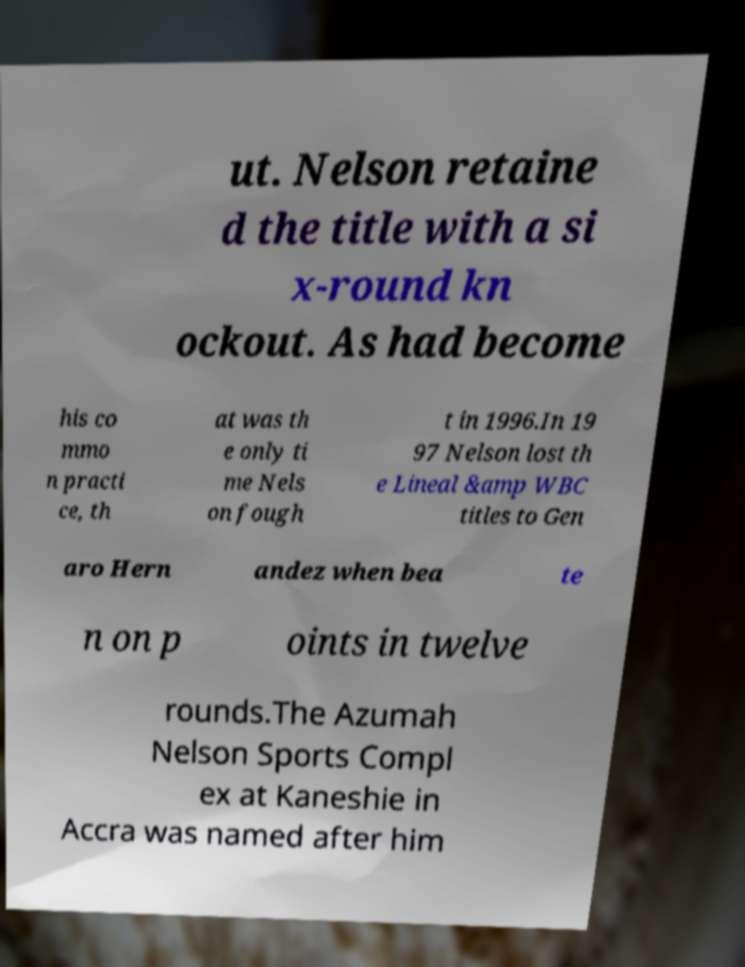I need the written content from this picture converted into text. Can you do that? ut. Nelson retaine d the title with a si x-round kn ockout. As had become his co mmo n practi ce, th at was th e only ti me Nels on fough t in 1996.In 19 97 Nelson lost th e Lineal &amp WBC titles to Gen aro Hern andez when bea te n on p oints in twelve rounds.The Azumah Nelson Sports Compl ex at Kaneshie in Accra was named after him 